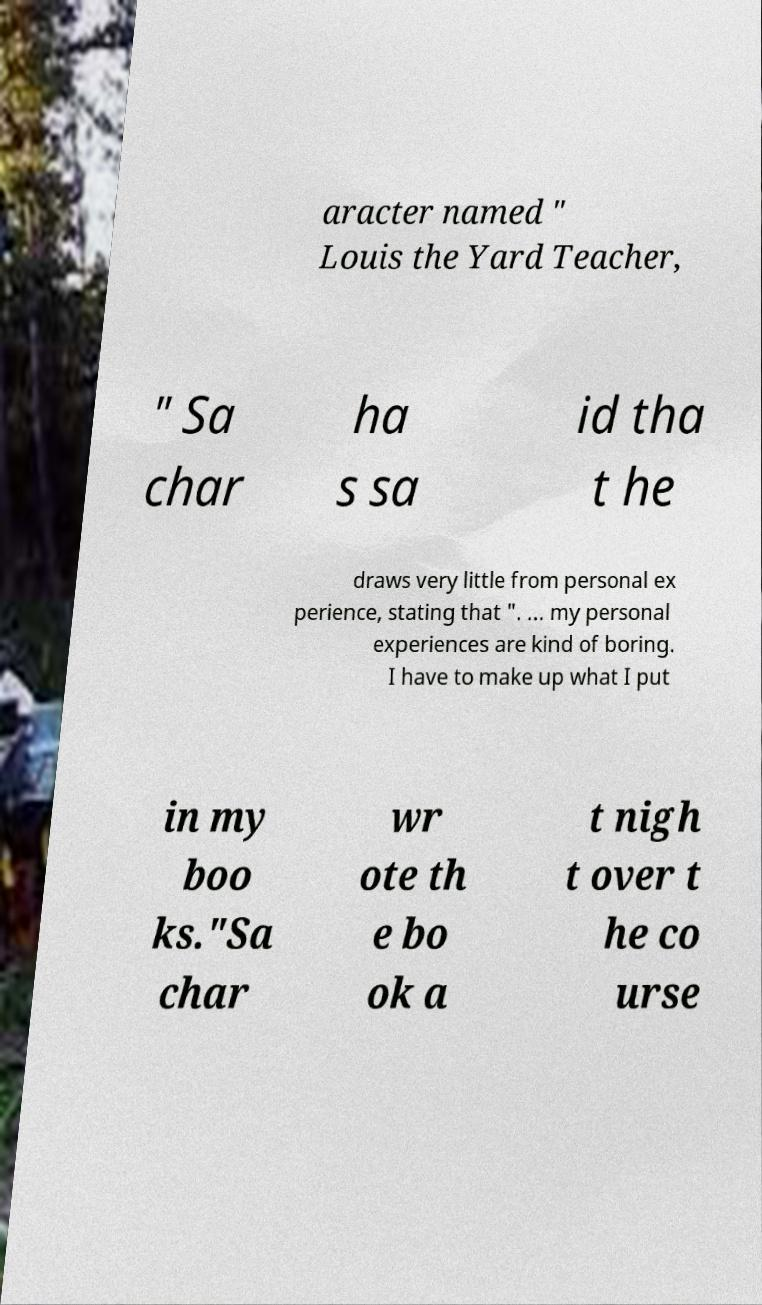Please read and relay the text visible in this image. What does it say? aracter named " Louis the Yard Teacher, " Sa char ha s sa id tha t he draws very little from personal ex perience, stating that ". ... my personal experiences are kind of boring. I have to make up what I put in my boo ks."Sa char wr ote th e bo ok a t nigh t over t he co urse 